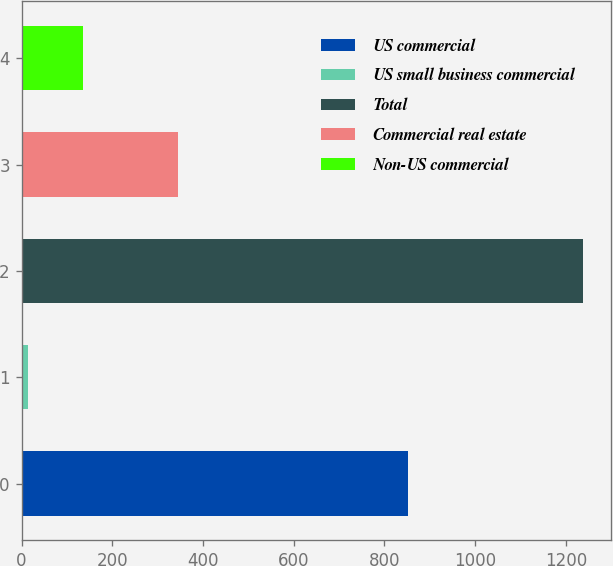Convert chart. <chart><loc_0><loc_0><loc_500><loc_500><bar_chart><fcel>US commercial<fcel>US small business commercial<fcel>Total<fcel>Commercial real estate<fcel>Non-US commercial<nl><fcel>853<fcel>14<fcel>1238<fcel>346<fcel>136.4<nl></chart> 